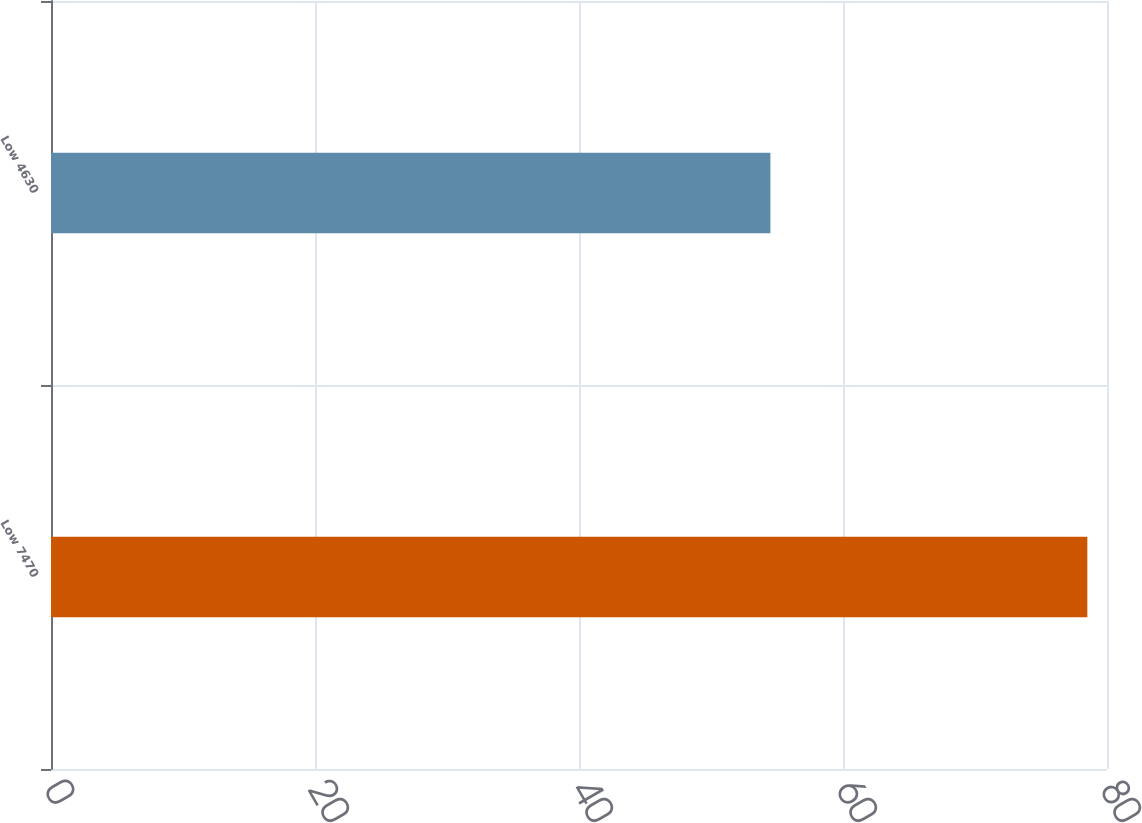Convert chart to OTSL. <chart><loc_0><loc_0><loc_500><loc_500><bar_chart><fcel>Low 7470<fcel>Low 4630<nl><fcel>78.51<fcel>54.5<nl></chart> 